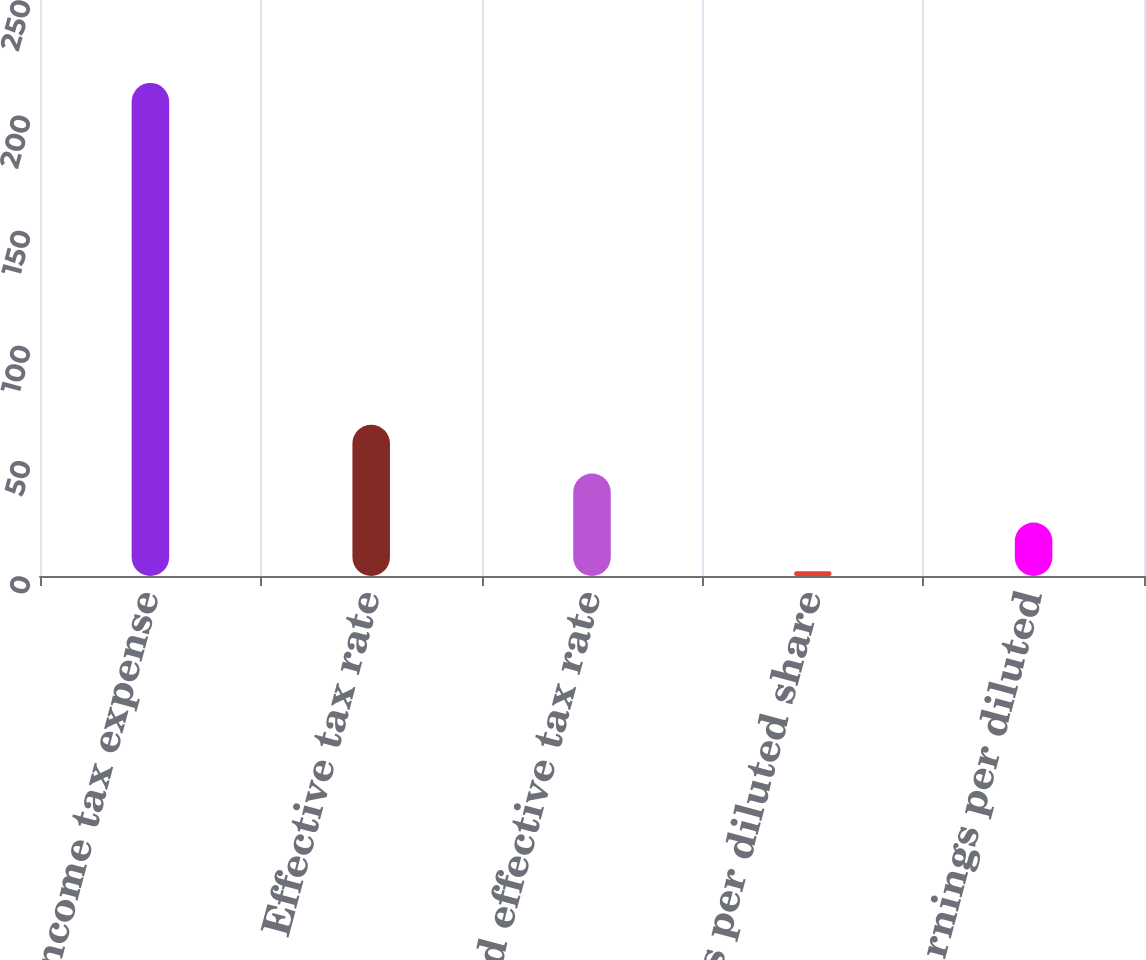Convert chart to OTSL. <chart><loc_0><loc_0><loc_500><loc_500><bar_chart><fcel>Income tax expense<fcel>Effective tax rate<fcel>Adjusted effective tax rate<fcel>Earnings per diluted share<fcel>Adjusted earnings per diluted<nl><fcel>214<fcel>65.64<fcel>44.44<fcel>2.04<fcel>23.24<nl></chart> 